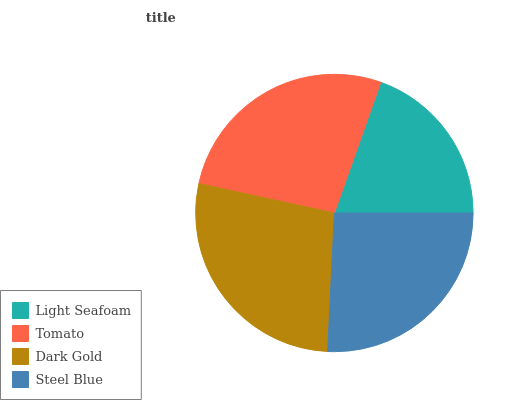Is Light Seafoam the minimum?
Answer yes or no. Yes. Is Dark Gold the maximum?
Answer yes or no. Yes. Is Tomato the minimum?
Answer yes or no. No. Is Tomato the maximum?
Answer yes or no. No. Is Tomato greater than Light Seafoam?
Answer yes or no. Yes. Is Light Seafoam less than Tomato?
Answer yes or no. Yes. Is Light Seafoam greater than Tomato?
Answer yes or no. No. Is Tomato less than Light Seafoam?
Answer yes or no. No. Is Tomato the high median?
Answer yes or no. Yes. Is Steel Blue the low median?
Answer yes or no. Yes. Is Light Seafoam the high median?
Answer yes or no. No. Is Light Seafoam the low median?
Answer yes or no. No. 